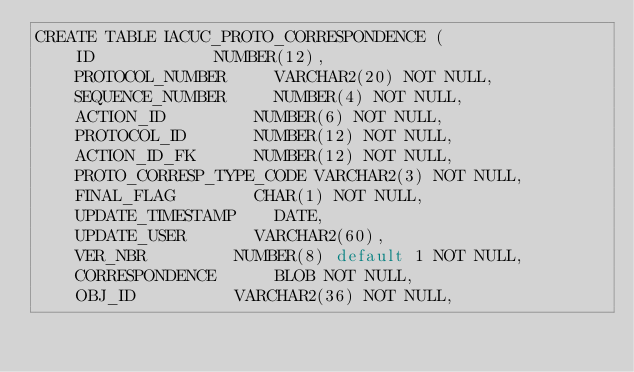<code> <loc_0><loc_0><loc_500><loc_500><_SQL_>CREATE TABLE IACUC_PROTO_CORRESPONDENCE (
    ID 						NUMBER(12),
    PROTOCOL_NUMBER 		VARCHAR2(20) NOT NULL,
    SEQUENCE_NUMBER		 	NUMBER(4) NOT NULL,
    ACTION_ID 				NUMBER(6) NOT NULL,
    PROTOCOL_ID 			NUMBER(12) NOT NULL,
    ACTION_ID_FK 			NUMBER(12) NOT NULL,
    PROTO_CORRESP_TYPE_CODE VARCHAR2(3) NOT NULL,
    FINAL_FLAG 				CHAR(1) NOT NULL,
    UPDATE_TIMESTAMP 		DATE,
    UPDATE_USER 			VARCHAR2(60),
    VER_NBR 				NUMBER(8) default 1 NOT NULL,
    CORRESPONDENCE 			BLOB NOT NULL,
    OBJ_ID 					VARCHAR2(36) NOT NULL,</code> 